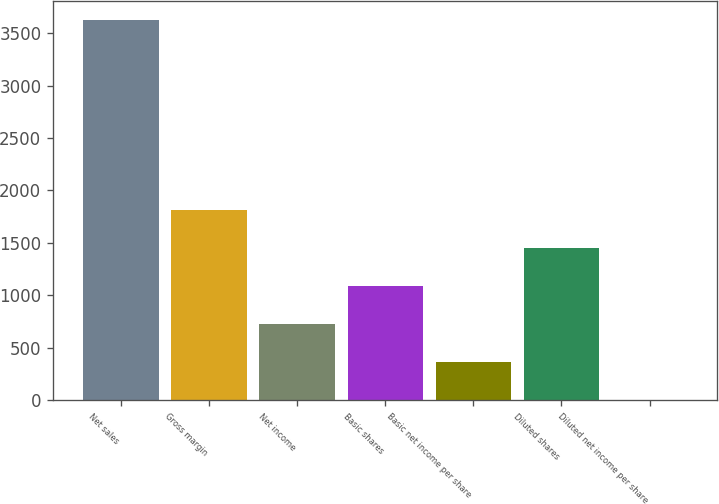Convert chart to OTSL. <chart><loc_0><loc_0><loc_500><loc_500><bar_chart><fcel>Net sales<fcel>Gross margin<fcel>Net income<fcel>Basic shares<fcel>Basic net income per share<fcel>Diluted shares<fcel>Diluted net income per share<nl><fcel>3624<fcel>1812.24<fcel>725.19<fcel>1087.54<fcel>362.84<fcel>1449.89<fcel>0.49<nl></chart> 